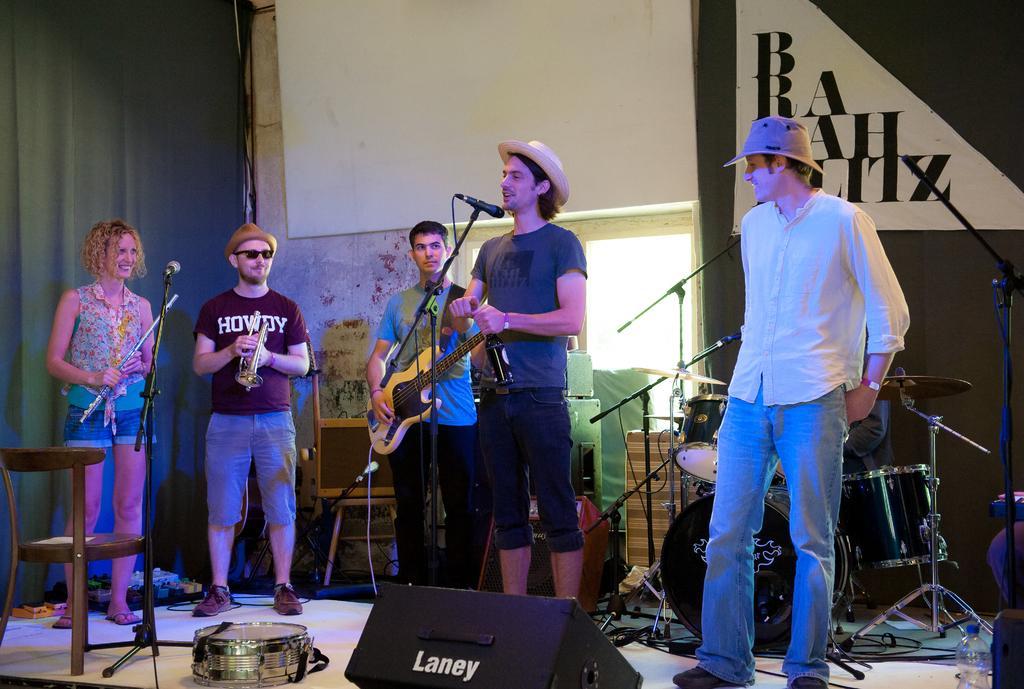How would you summarize this image in a sentence or two? In this picture there is a man who is holding a bottle. There is another man who is playing guitar. There is a person who is holding saxophone. There is a woman holding a flute. At the background there are musical instruments. 